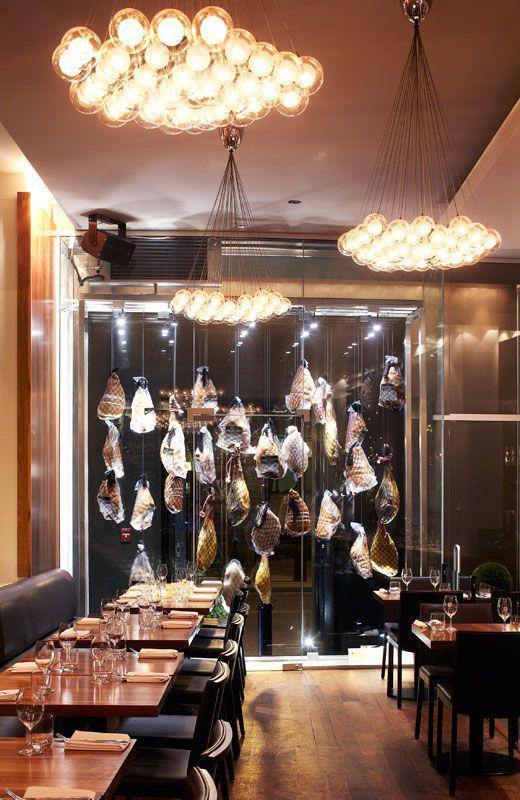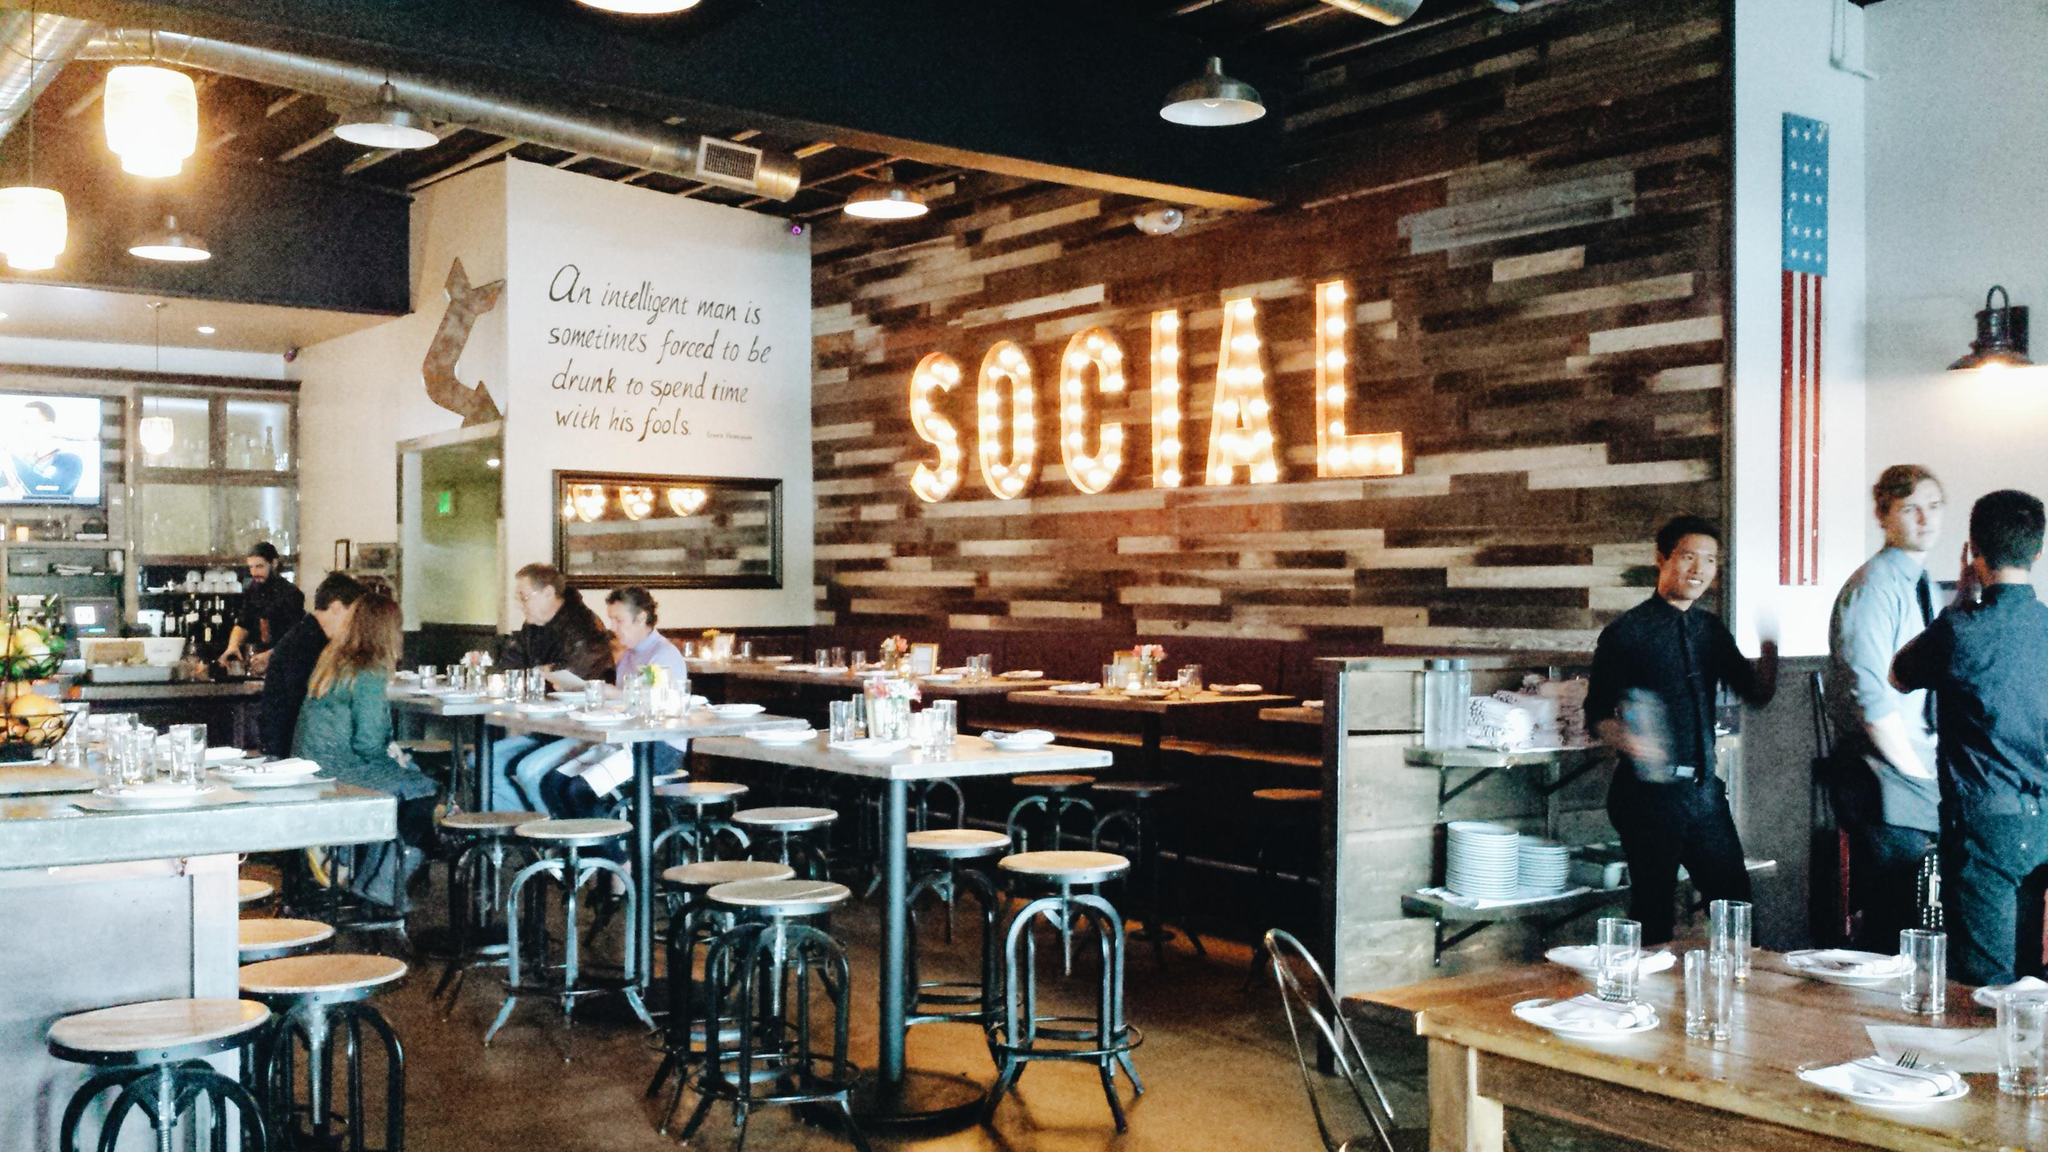The first image is the image on the left, the second image is the image on the right. For the images displayed, is the sentence "There are some lighting fixtures on the rear walls, instead of just on the ceilings." factually correct? Answer yes or no. Yes. The first image is the image on the left, the second image is the image on the right. For the images displayed, is the sentence "One of the images features a restaurant with textual wall art." factually correct? Answer yes or no. Yes. 